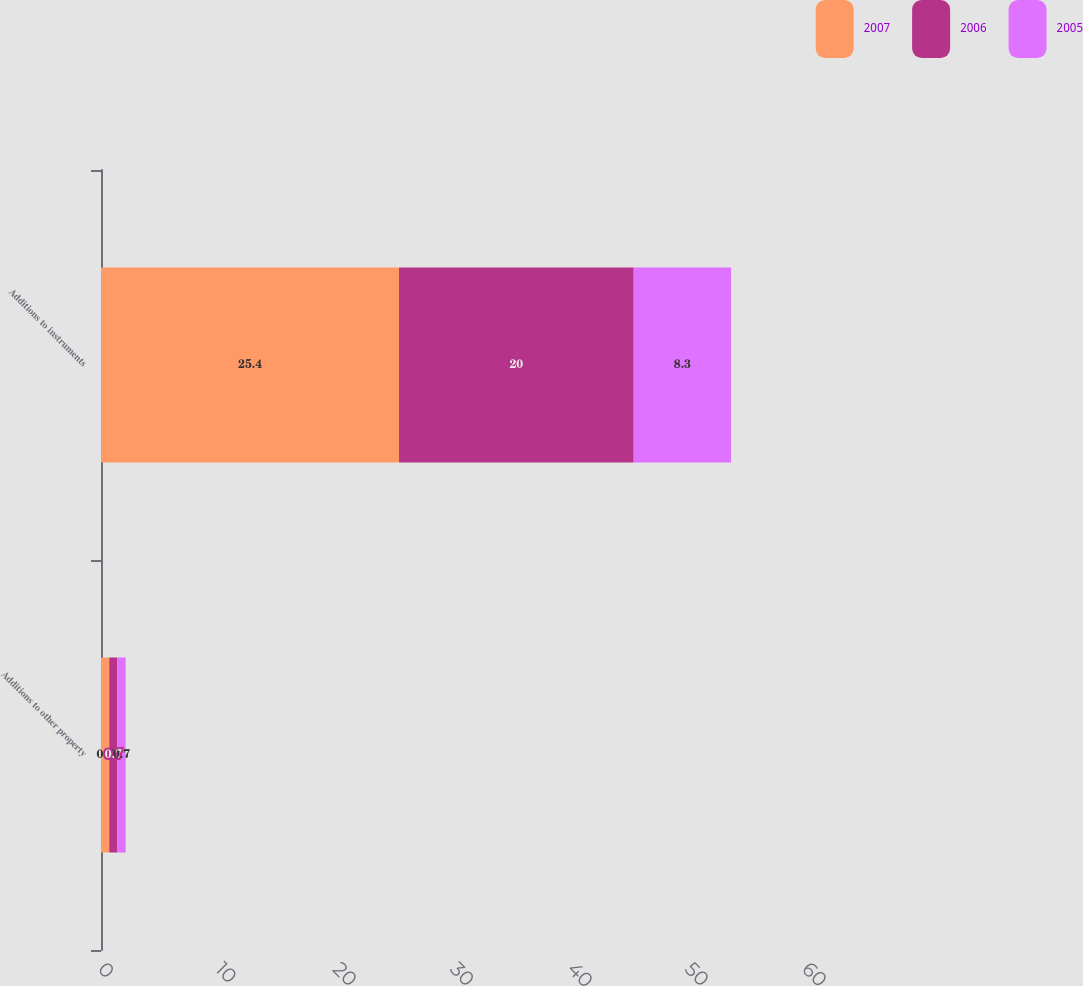Convert chart. <chart><loc_0><loc_0><loc_500><loc_500><stacked_bar_chart><ecel><fcel>Additions to other property<fcel>Additions to instruments<nl><fcel>2007<fcel>0.7<fcel>25.4<nl><fcel>2006<fcel>0.7<fcel>20<nl><fcel>2005<fcel>0.7<fcel>8.3<nl></chart> 